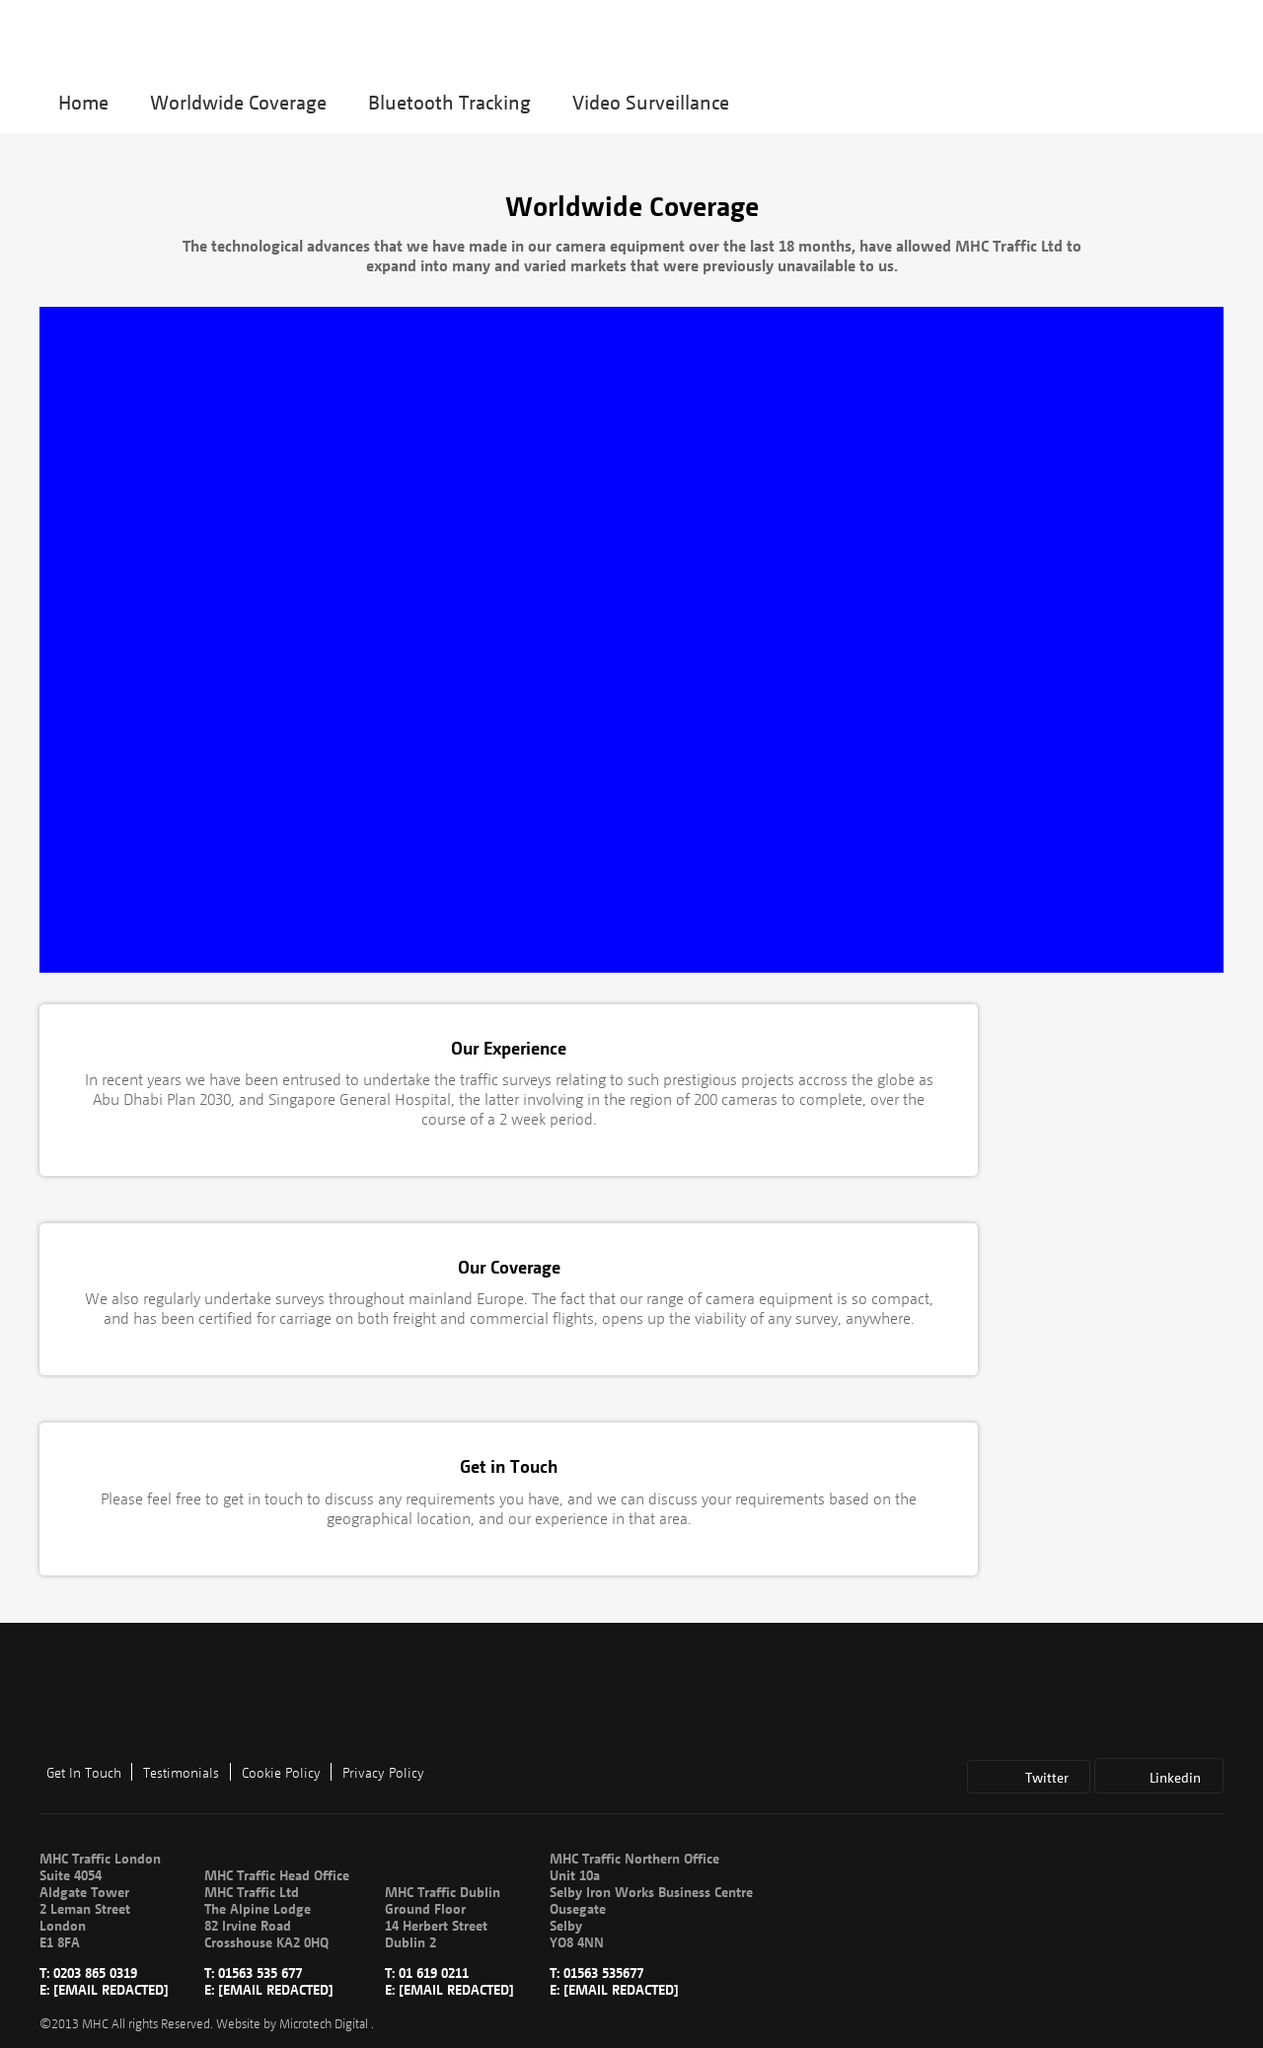How does this website ensure it meets global accessibility standards? To comply with global accessibility standards, this website uses semantic HTML to support screen readers, maintains high contrast ratios for readability, and provides alternative text for images. It ensures all interactive elements are accessible via keyboard and inputs are clearly labeled to assist users with disabilities. Can you suggest improvements for the accessibility features mentioned in the last answer? Improving accessibility could involve incorporating ARIA (Accessible Rich Internet Applications) roles to help users navigate more complex elements, routinely testing with real users to uncover usability challenges, and possibly providing captions or sign language interpretations for video content. Furthermore, ensuring that all functionalities are operable through a combination of voice commands and gestures could make navigation easier for users with motor impairments. 